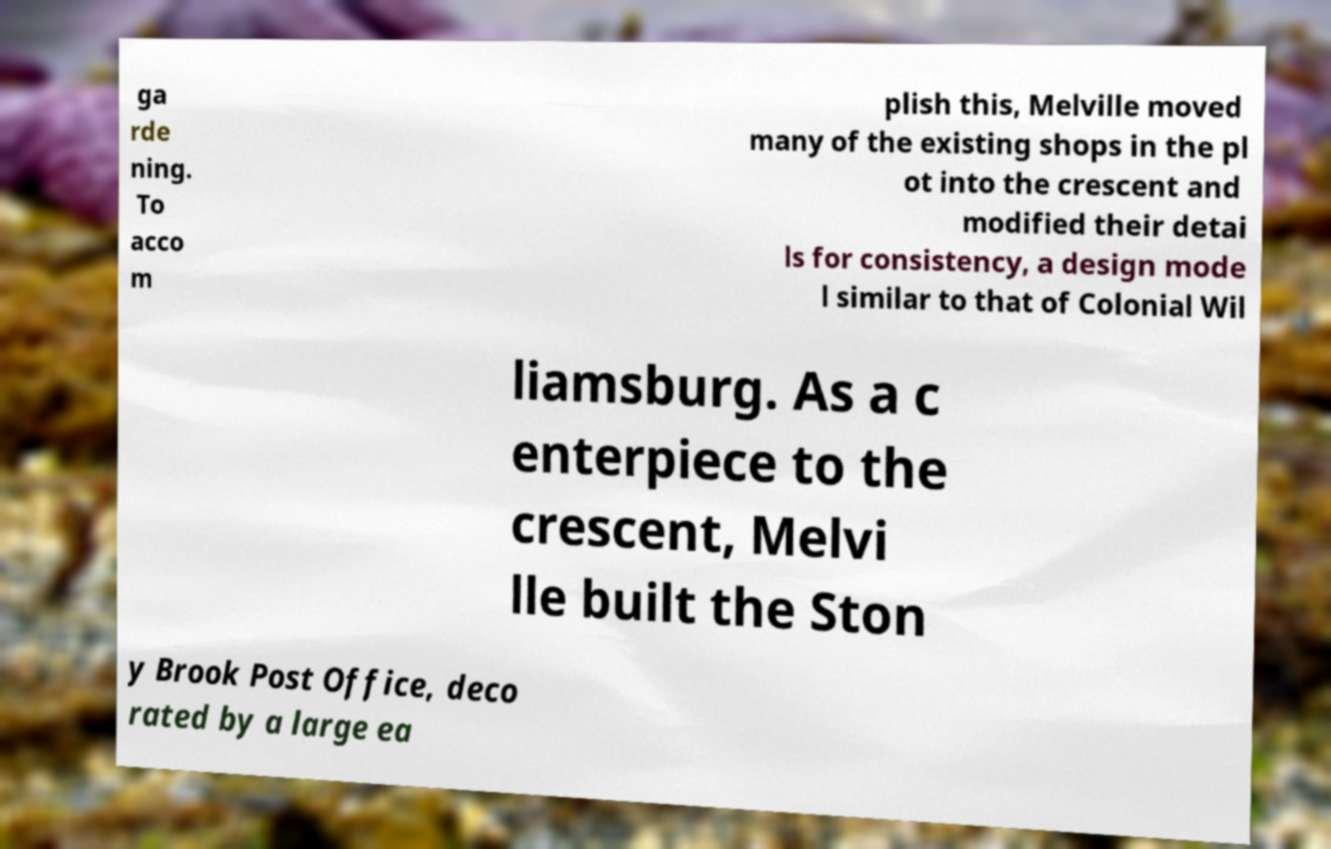For documentation purposes, I need the text within this image transcribed. Could you provide that? ga rde ning. To acco m plish this, Melville moved many of the existing shops in the pl ot into the crescent and modified their detai ls for consistency, a design mode l similar to that of Colonial Wil liamsburg. As a c enterpiece to the crescent, Melvi lle built the Ston y Brook Post Office, deco rated by a large ea 